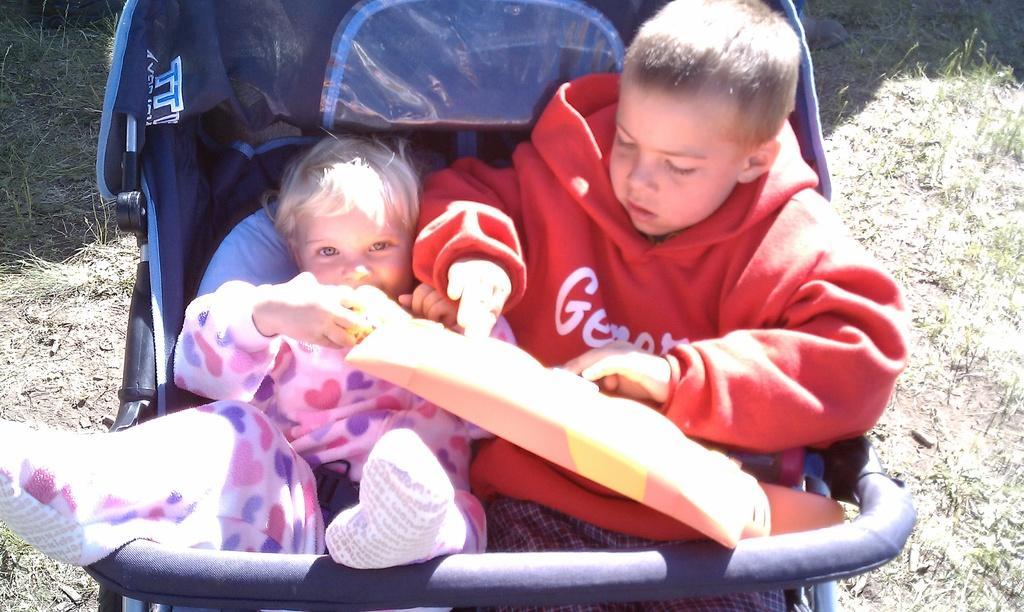Could you give a brief overview of what you see in this image? In this picture we can see two kids in a stroller. At the bottom there is grass and soil. 